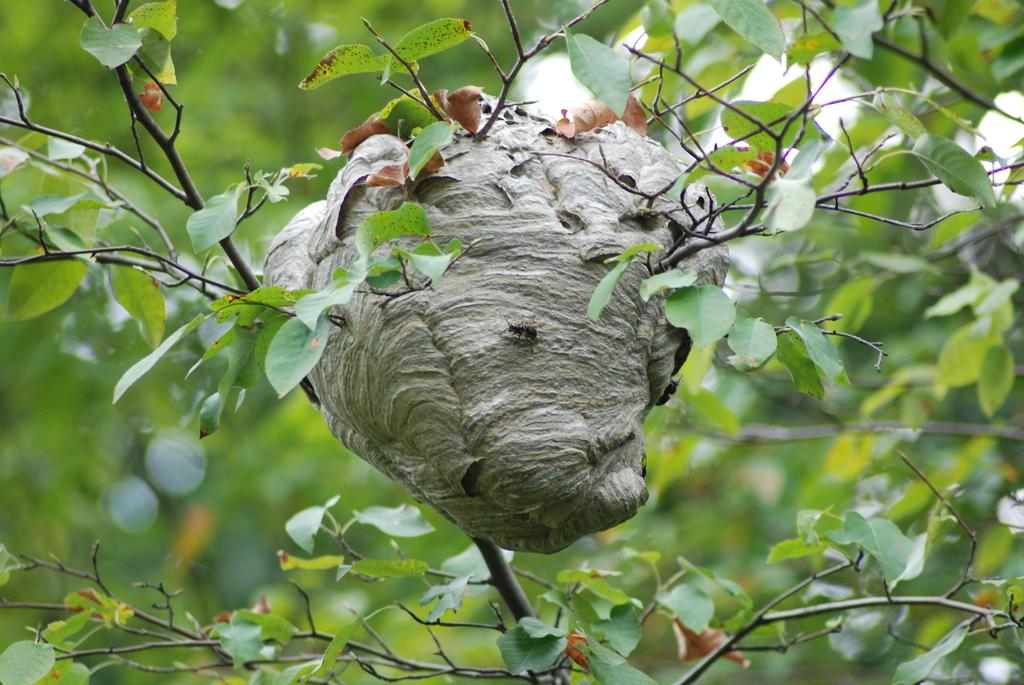What can be observed about the background of the image? The background portion of the picture is blurred. What type of vegetation is present in the image? There are leaves and branches in the image. What is the insect's location in the image? The insect is on a nest in the image. What color is the credit card in the image? There is no credit card present in the image. How does the balloon affect the branches in the image? There is no balloon present in the image, so it cannot affect the branches. 